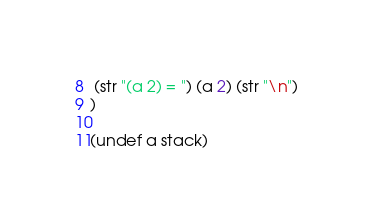<code> <loc_0><loc_0><loc_500><loc_500><_Crystal_> (str "(a 2) = ") (a 2) (str "\n")
)

(undef a stack)
</code> 